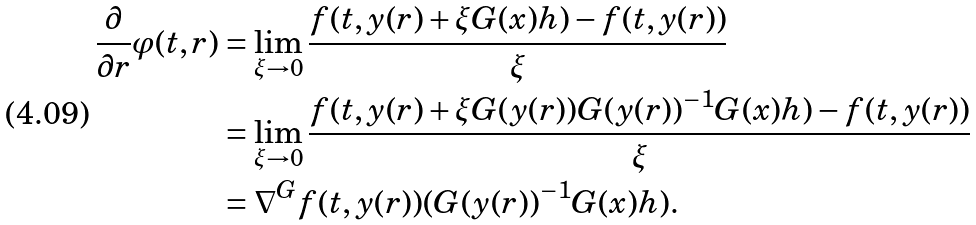Convert formula to latex. <formula><loc_0><loc_0><loc_500><loc_500>\frac { \partial } { \partial r } \varphi ( t , r ) & = \lim _ { \xi \to 0 } \frac { f ( t , y ( r ) + \xi G ( x ) h ) - f ( t , y ( r ) ) } { \xi } \\ & = \lim _ { \xi \to 0 } \frac { f ( t , y ( r ) + \xi G ( y ( r ) ) G ( y ( r ) ) ^ { - 1 } G ( x ) h ) - f ( t , y ( r ) ) } { \xi } \\ & = \nabla ^ { G } f ( t , y ( r ) ) ( G ( y ( r ) ) ^ { - 1 } G ( x ) h ) .</formula> 